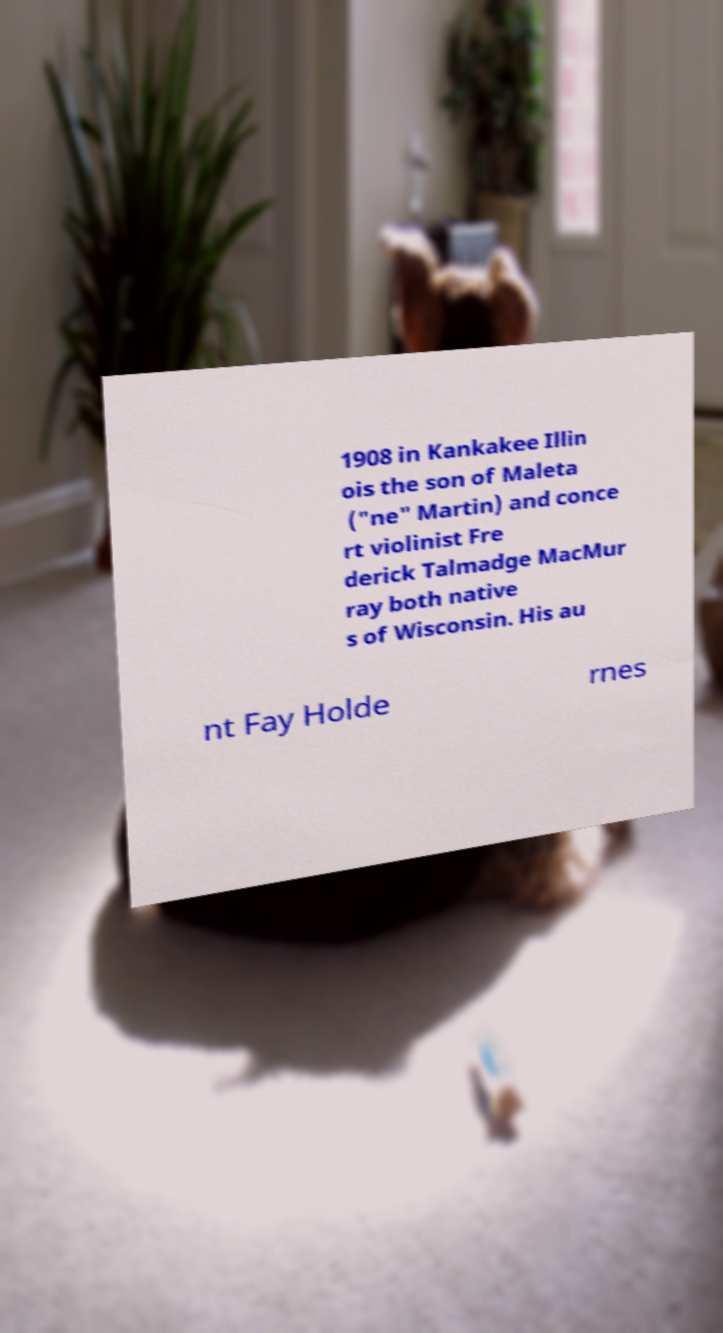What messages or text are displayed in this image? I need them in a readable, typed format. 1908 in Kankakee Illin ois the son of Maleta ("ne" Martin) and conce rt violinist Fre derick Talmadge MacMur ray both native s of Wisconsin. His au nt Fay Holde rnes 